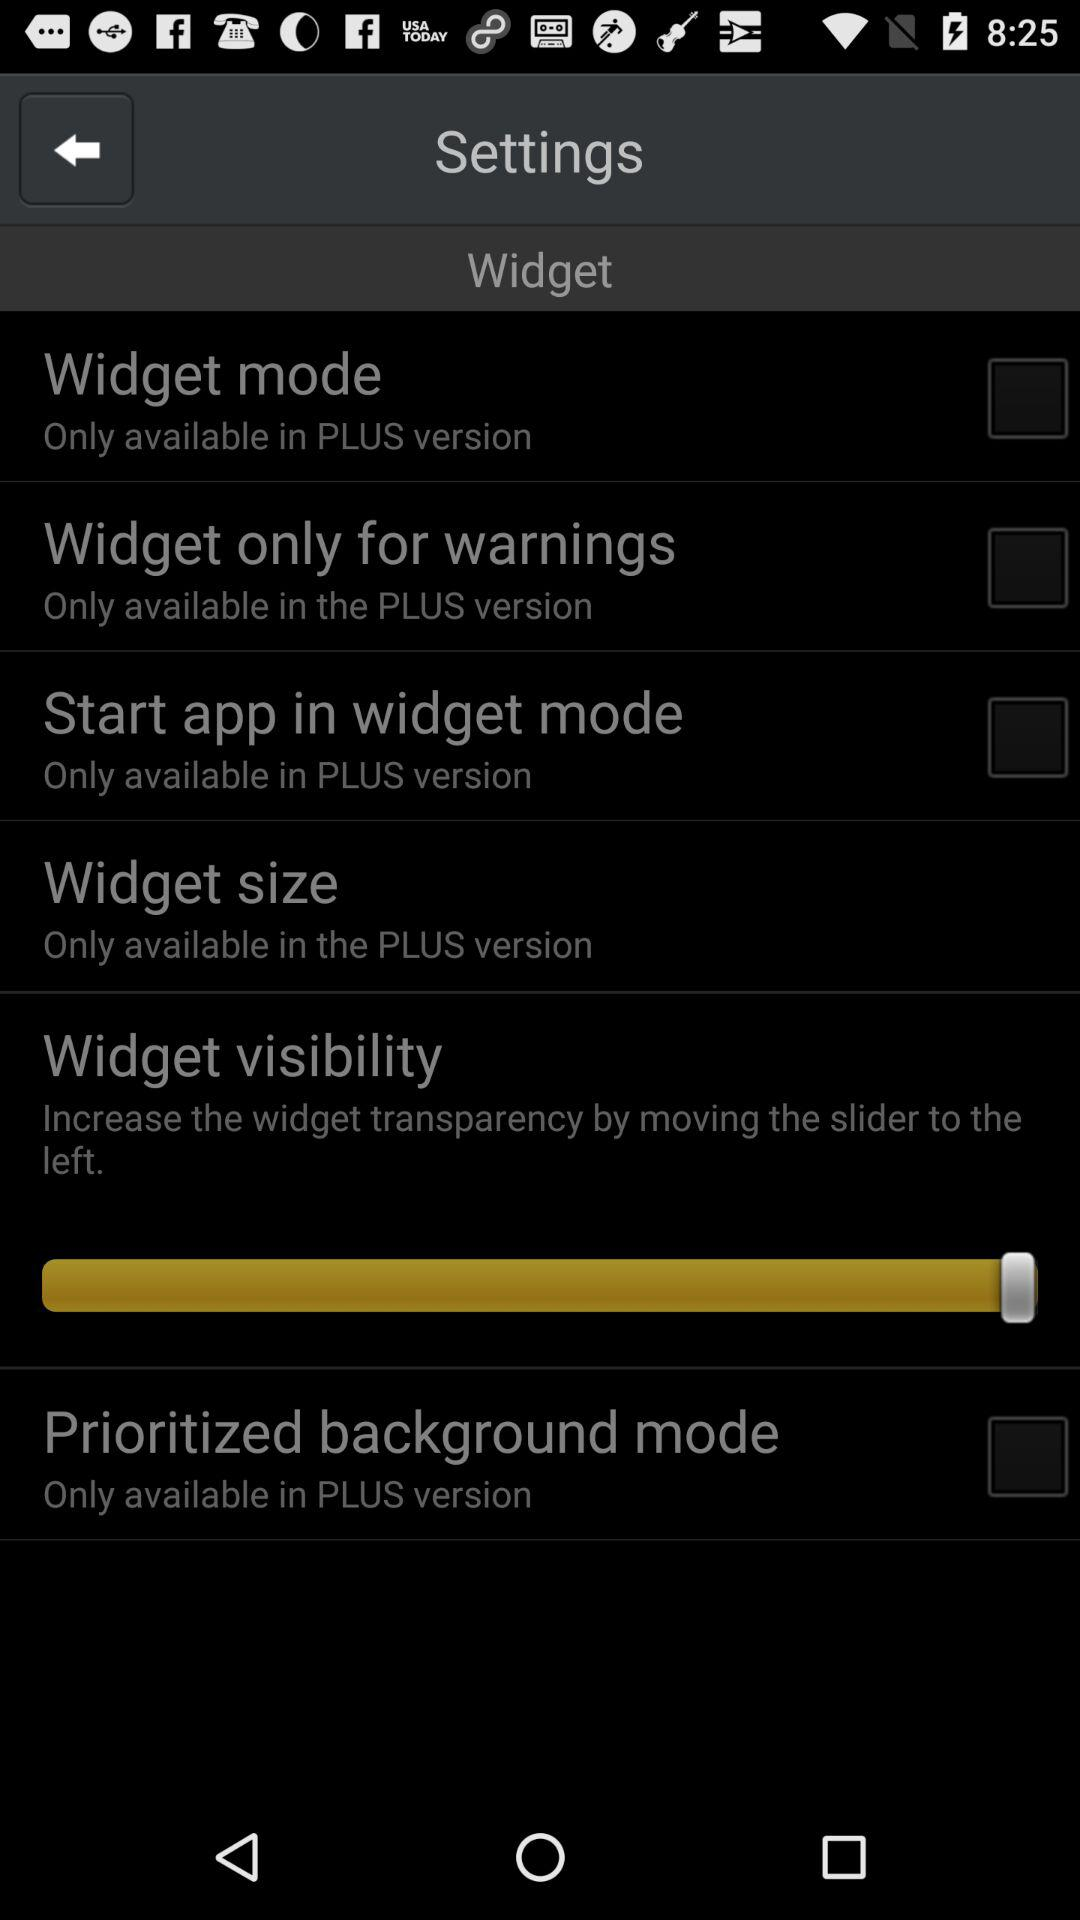In which version is the widget size only available? The widget size is only available in the PLUS version. 